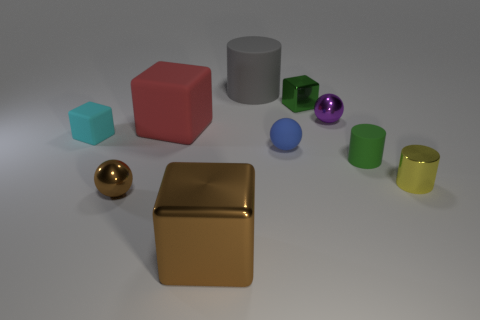What number of yellow objects have the same material as the gray object?
Your answer should be very brief. 0. How big is the thing that is behind the tiny green metal cube behind the small metal ball on the left side of the blue thing?
Offer a terse response. Large. There is a tiny cyan cube; how many purple objects are to the right of it?
Your answer should be compact. 1. Is the number of big red rubber things greater than the number of large red matte balls?
Offer a very short reply. Yes. What size is the cube that is on the right side of the large matte block and behind the small cyan matte thing?
Make the answer very short. Small. The ball that is in front of the tiny metal cylinder in front of the green object that is to the right of the tiny shiny cube is made of what material?
Your answer should be very brief. Metal. What material is the thing that is the same color as the tiny metallic block?
Keep it short and to the point. Rubber. Is the color of the sphere that is to the left of the large rubber cylinder the same as the large metal cube that is on the right side of the tiny brown object?
Your answer should be compact. Yes. There is a tiny green object that is behind the green thing in front of the small cube in front of the green cube; what is its shape?
Give a very brief answer. Cube. There is a metal object that is in front of the tiny blue rubber thing and behind the brown metal sphere; what shape is it?
Your response must be concise. Cylinder. 